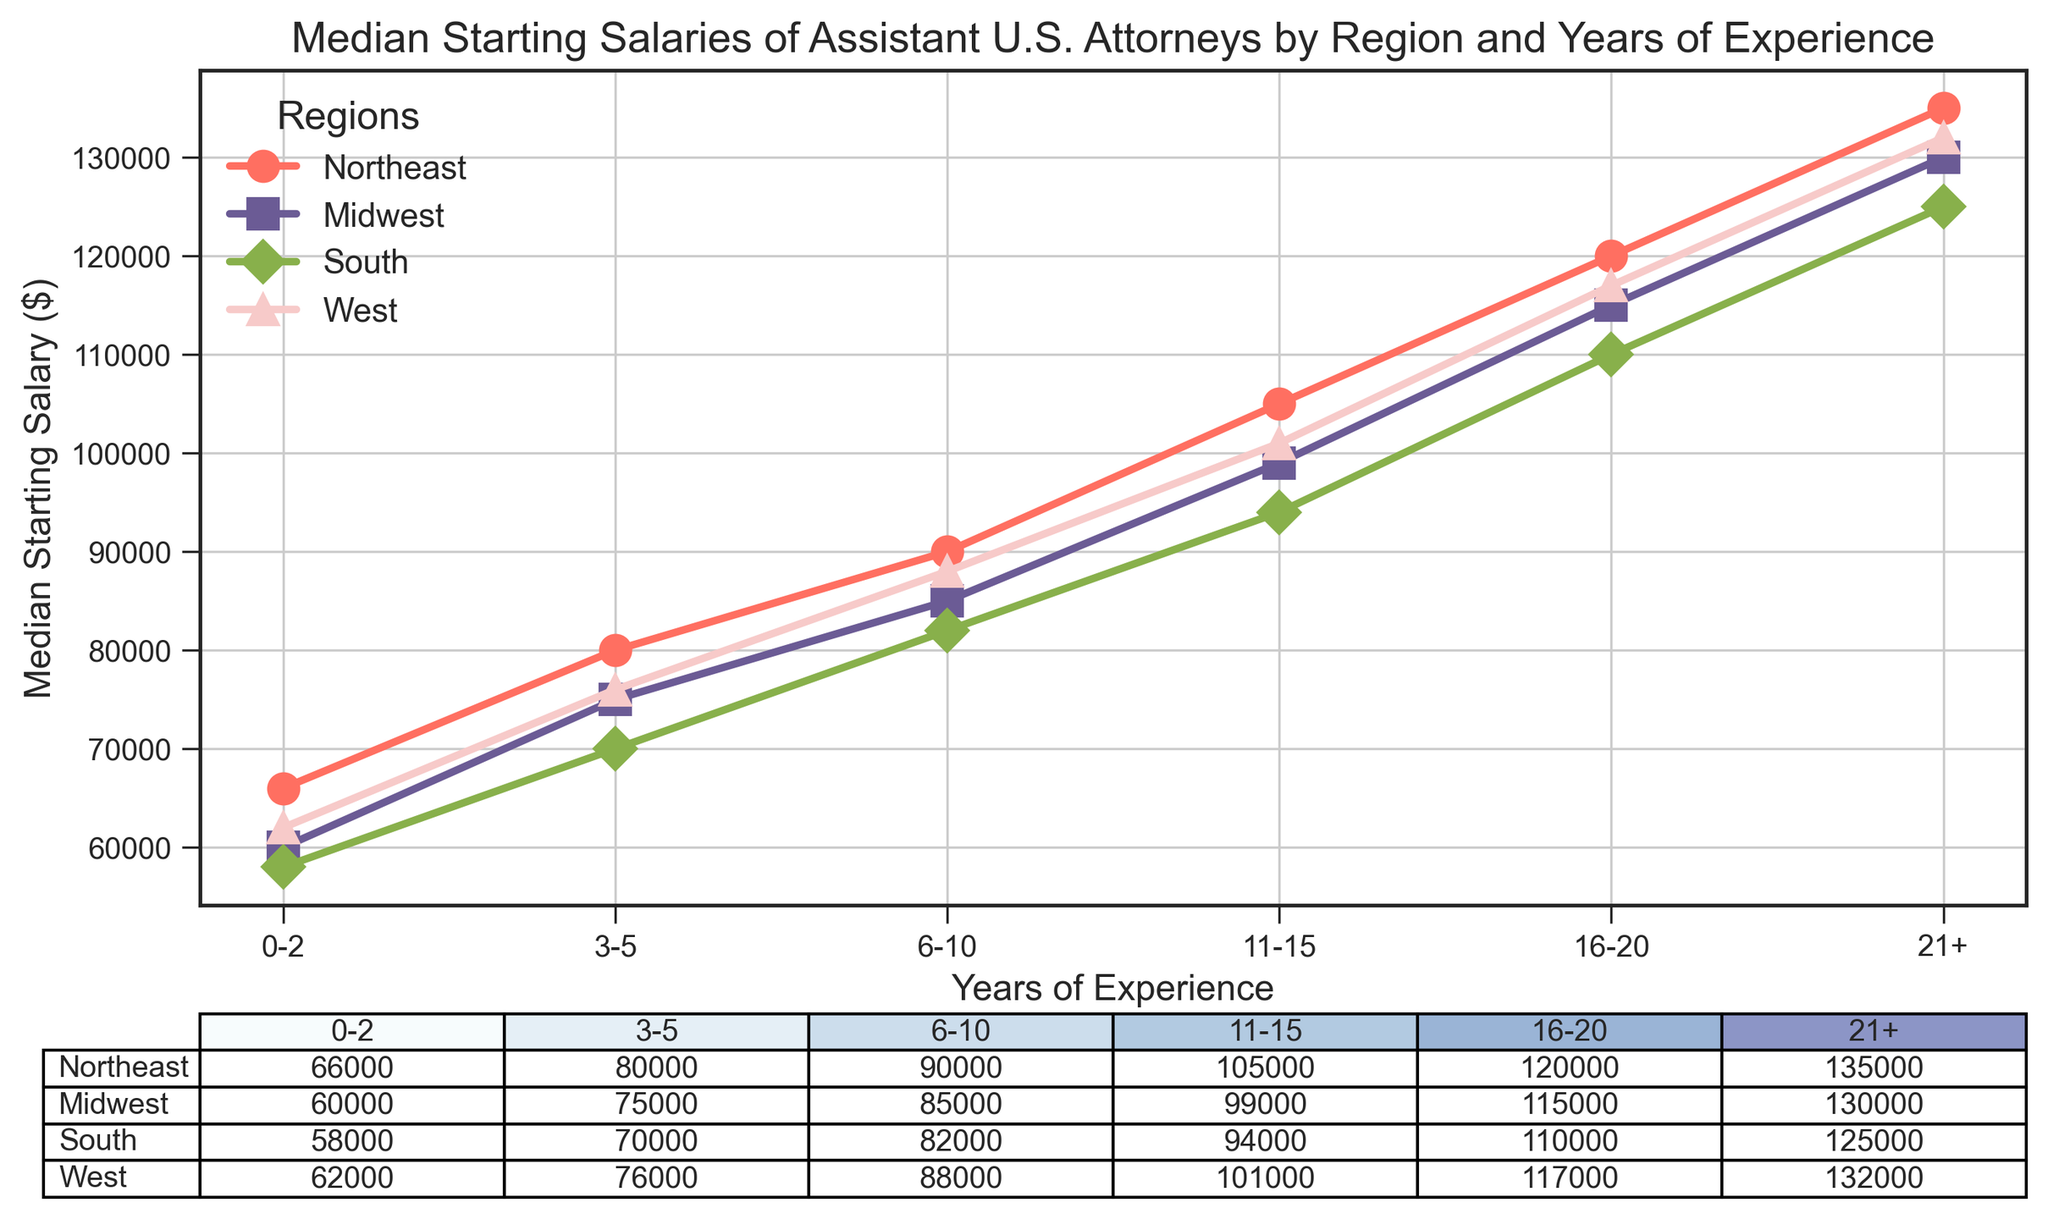What is the median starting salary for an Assistant U.S. Attorney with 11-15 years of experience in the Northeast region? Locate the row for the Northeast region and the column for 11-15 years of experience, then find the intersecting cell value. The table shows $105,000 for this case.
Answer: $105,000 Which region has the lowest median starting salary for entry-level positions (0-2 years)? Compare the salary values for 0-2 years of experience across all four regions: Northeast ($66,000), Midwest ($60,000), South ($58,000), and West ($62,000). The lowest is $58,000 in the South.
Answer: South By how much does the median starting salary increase from 0-2 years to 21+ years of experience in the Midwest region? Find the difference between the median starting salary at 21+ years ($130,000) and at 0-2 years ($60,000) in the Midwest. The difference is $130,000 - $60,000.
Answer: $70,000 What's the average median starting salary for Assistant U.S. Attorneys with 6-10 years of experience across all regions? Calculate the average of the median starting salaries for 6-10 years of experience: ($90,000 + $85,000 + $82,000 + $88,000) / 4. The sum is $345,000, so the average is $345,000 / 4.
Answer: $86,250 Which region shows the highest median starting salary for those with 16-20 years of experience? Compare the median starting salaries for 16-20 years of experience across all regions: Northeast ($120,000), Midwest ($115,000), South ($110,000), and West ($117,000). The highest is $120,000 in the Northeast.
Answer: Northeast How do the median starting salaries compare between the Midwest and South regions for those with 11-15 years of experience? Locate the salary for 11-15 years of experience in both regions: Midwest ($99,000) and South ($94,000). The Midwest has a higher salary than the South by $5,000.
Answer: The Midwest is $5,000 higher What is the progression of median starting salaries for the West region from 0-2 years to 21+ years? Examine the values for the West region across the experience levels: 0-2 years ($62,000), 3-5 years ($76,000), 6-10 years ($88,000), 11-15 years ($101,000), 16-20 years ($117,000), 21+ years ($132,000). The progression shows a steady increase in median starting salaries with more experience.
Answer: Steady increase Which experience level sees the smallest range of median starting salaries across all regions? Calculate the range (difference between maximum and minimum) for each experience level: 0-2 years ($66,000-$58,000=$8,000), 3-5 years ($80,000-$70,000=$10,000), 6-10 years ($90,000-$82,000=$8,000), 11-15 years ($105,000-$94,000=$11,000), 16-20 years ($120,000-$110,000=$10,000), 21+ years ($135,000-$125,000=$10,000). The smallest range is $8,000, seen for both the 0-2 and 6-10 years experience levels.
Answer: 0-2 and 6-10 years By what percentage does the median starting salary increase from 3-5 years to 6-10 years of experience in the Northeast region? First, calculate the increase: $90,000 - $80,000 = $10,000. Then calculate the percentage increase: ($10,000 / $80,000) * 100%.
Answer: 12.5% 